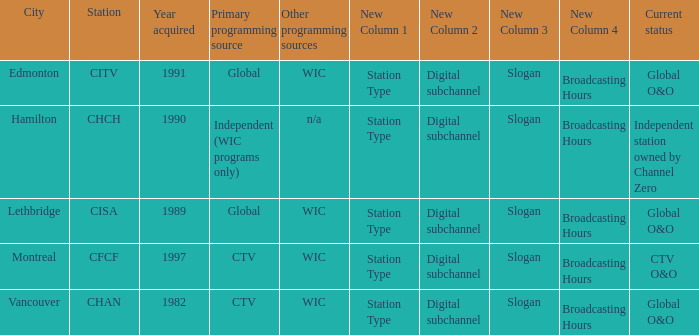Which station is located in edmonton CITV. 